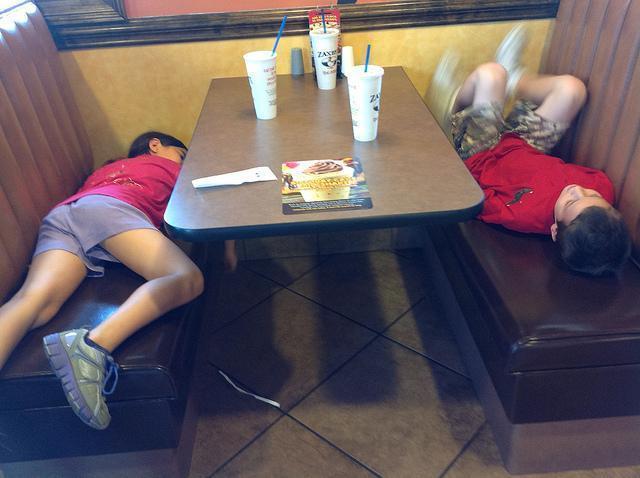How many chairs can you see?
Give a very brief answer. 2. How many people are there?
Give a very brief answer. 2. How many couches are visible?
Give a very brief answer. 2. How many toilets are in the room?
Give a very brief answer. 0. 